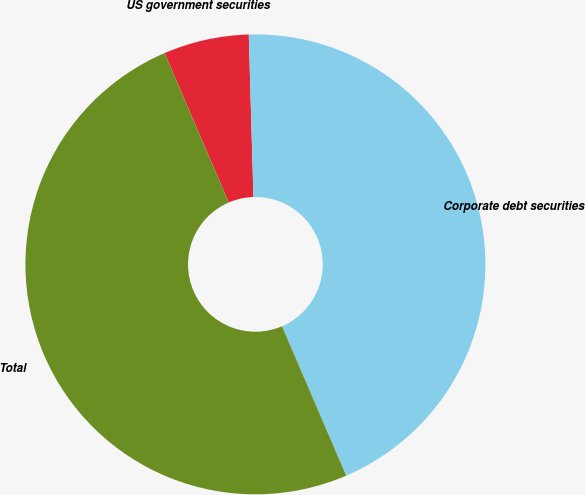Convert chart. <chart><loc_0><loc_0><loc_500><loc_500><pie_chart><fcel>US government securities<fcel>Corporate debt securities<fcel>Total<nl><fcel>6.0%<fcel>44.0%<fcel>50.0%<nl></chart> 